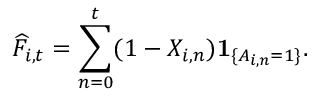<formula> <loc_0><loc_0><loc_500><loc_500>\widehat { F } _ { i , t } = \sum _ { n = 0 } ^ { t } ( 1 - X _ { i , n } ) 1 _ { \{ A _ { i , n } = 1 \} } .</formula> 